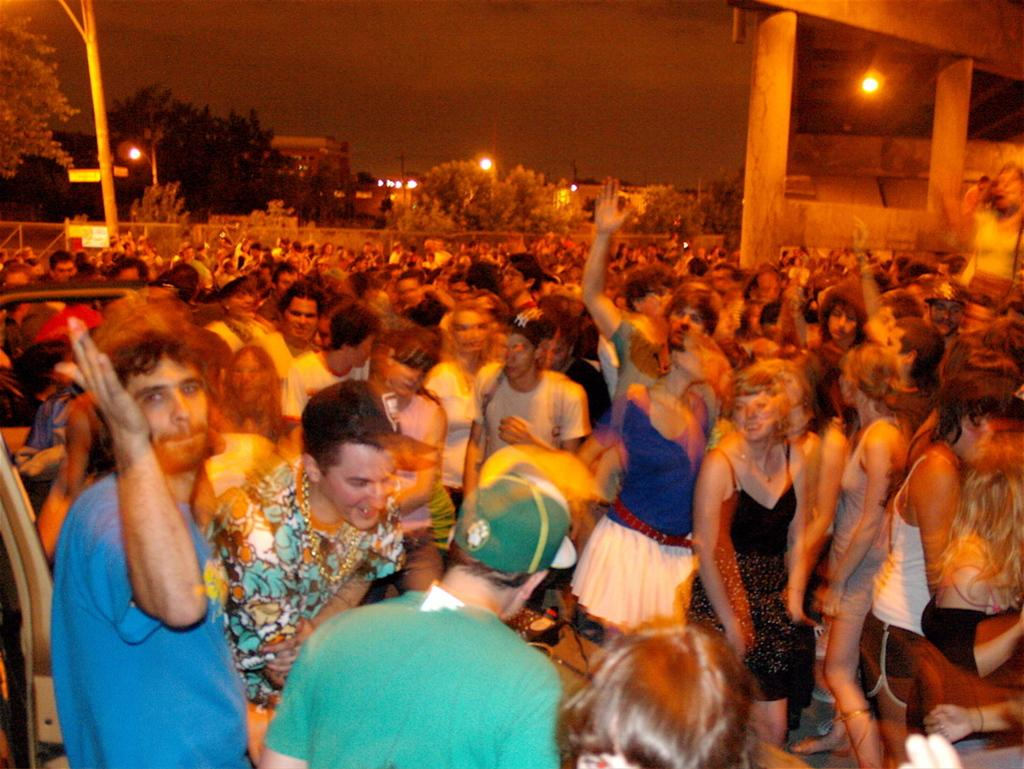What event is taking place in the image? The image is taken at a concert. What are the people in the foreground of the picture doing? There are people dancing in the foreground of the picture. What can be seen in the background of the picture? There are lights, poles, trees, and other objects in the background of the picture. What type of stocking is being used to hold the hydrant in the image? There is no stocking or hydrant present in the image. How is the glue being used in the image? There is no glue present in the image. 